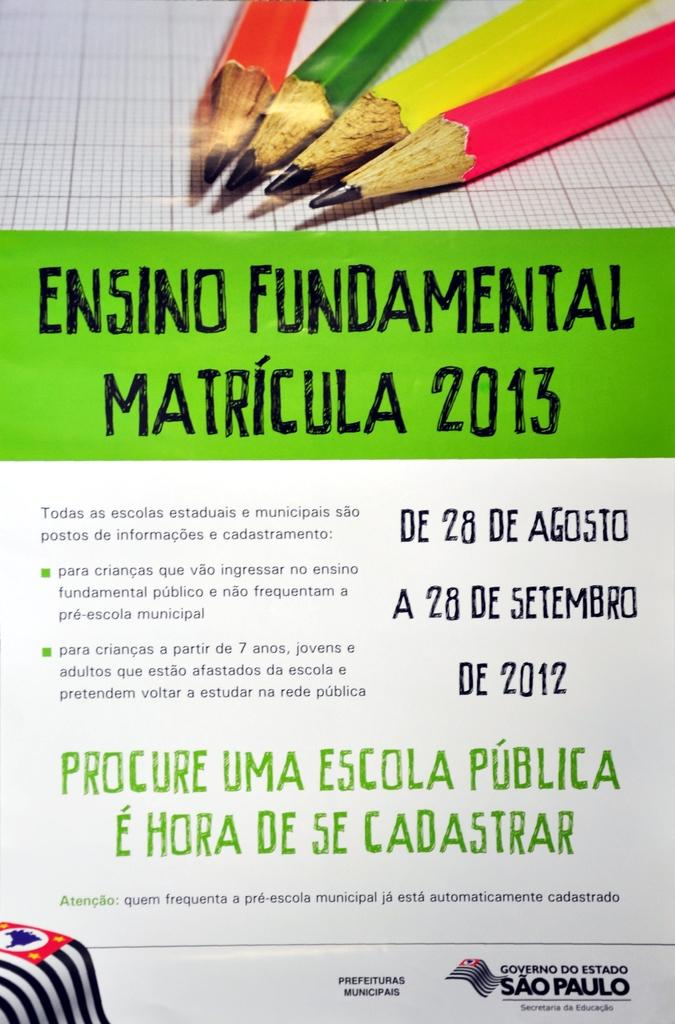What is present on the paper in the image? There are texts written on the paper. What else can be seen in the image besides the paper? There is an image of pencils in the image. How many fowl are visible in the image? There are no fowl present in the image. What type of rock is being used as a paperweight in the image? There is no rock present in the image, and the paper is not being held down by any object. 